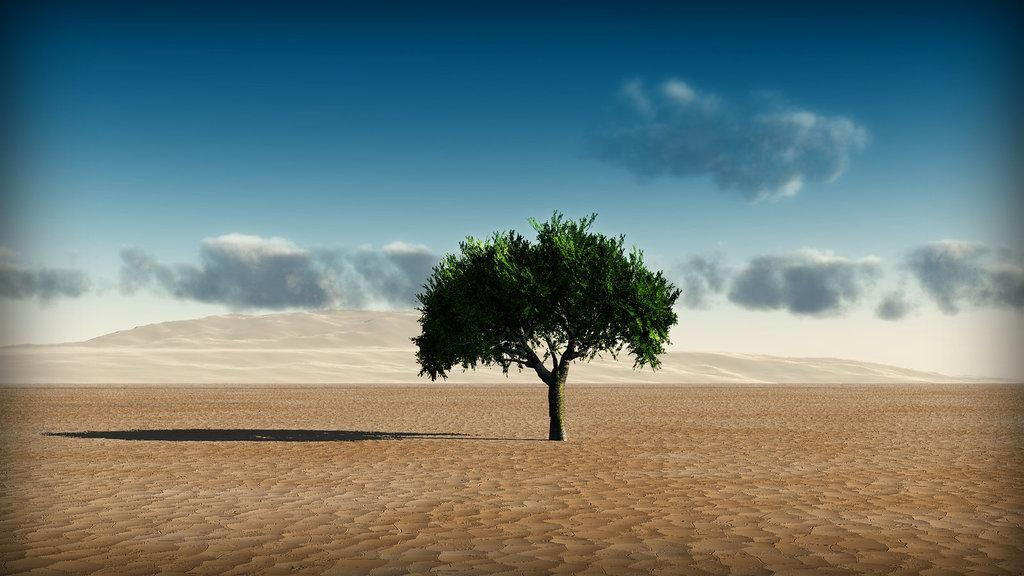What type of landscape is shown in the image? The image depicts a desert. What can be seen in the middle of the desert? There is a tree in the middle of the image. What is visible in the background of the image? The sky is visible in the background of the image. Can you see a kitten sitting on a plane seat in the image? No, there is no kitten or plane seat present in the image; it depicts a desert landscape with a tree in the middle. 